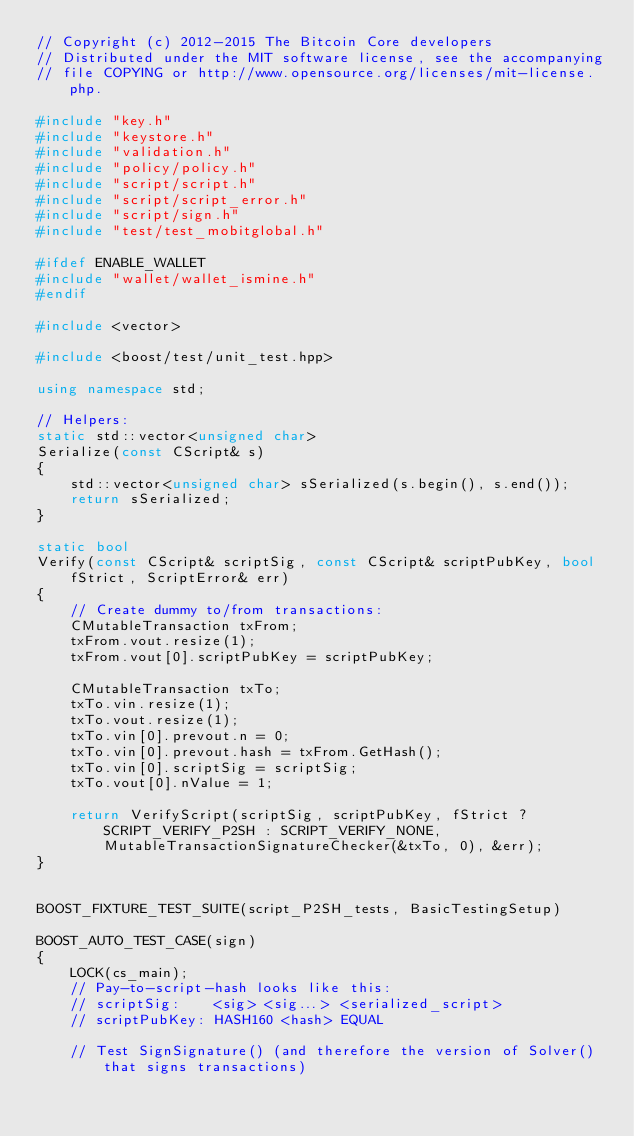Convert code to text. <code><loc_0><loc_0><loc_500><loc_500><_C++_>// Copyright (c) 2012-2015 The Bitcoin Core developers
// Distributed under the MIT software license, see the accompanying
// file COPYING or http://www.opensource.org/licenses/mit-license.php.

#include "key.h"
#include "keystore.h"
#include "validation.h"
#include "policy/policy.h"
#include "script/script.h"
#include "script/script_error.h"
#include "script/sign.h"
#include "test/test_mobitglobal.h"

#ifdef ENABLE_WALLET
#include "wallet/wallet_ismine.h"
#endif

#include <vector>

#include <boost/test/unit_test.hpp>

using namespace std;

// Helpers:
static std::vector<unsigned char>
Serialize(const CScript& s)
{
    std::vector<unsigned char> sSerialized(s.begin(), s.end());
    return sSerialized;
}

static bool
Verify(const CScript& scriptSig, const CScript& scriptPubKey, bool fStrict, ScriptError& err)
{
    // Create dummy to/from transactions:
    CMutableTransaction txFrom;
    txFrom.vout.resize(1);
    txFrom.vout[0].scriptPubKey = scriptPubKey;

    CMutableTransaction txTo;
    txTo.vin.resize(1);
    txTo.vout.resize(1);
    txTo.vin[0].prevout.n = 0;
    txTo.vin[0].prevout.hash = txFrom.GetHash();
    txTo.vin[0].scriptSig = scriptSig;
    txTo.vout[0].nValue = 1;

    return VerifyScript(scriptSig, scriptPubKey, fStrict ? SCRIPT_VERIFY_P2SH : SCRIPT_VERIFY_NONE, MutableTransactionSignatureChecker(&txTo, 0), &err);
}


BOOST_FIXTURE_TEST_SUITE(script_P2SH_tests, BasicTestingSetup)

BOOST_AUTO_TEST_CASE(sign)
{
    LOCK(cs_main);
    // Pay-to-script-hash looks like this:
    // scriptSig:    <sig> <sig...> <serialized_script>
    // scriptPubKey: HASH160 <hash> EQUAL

    // Test SignSignature() (and therefore the version of Solver() that signs transactions)</code> 